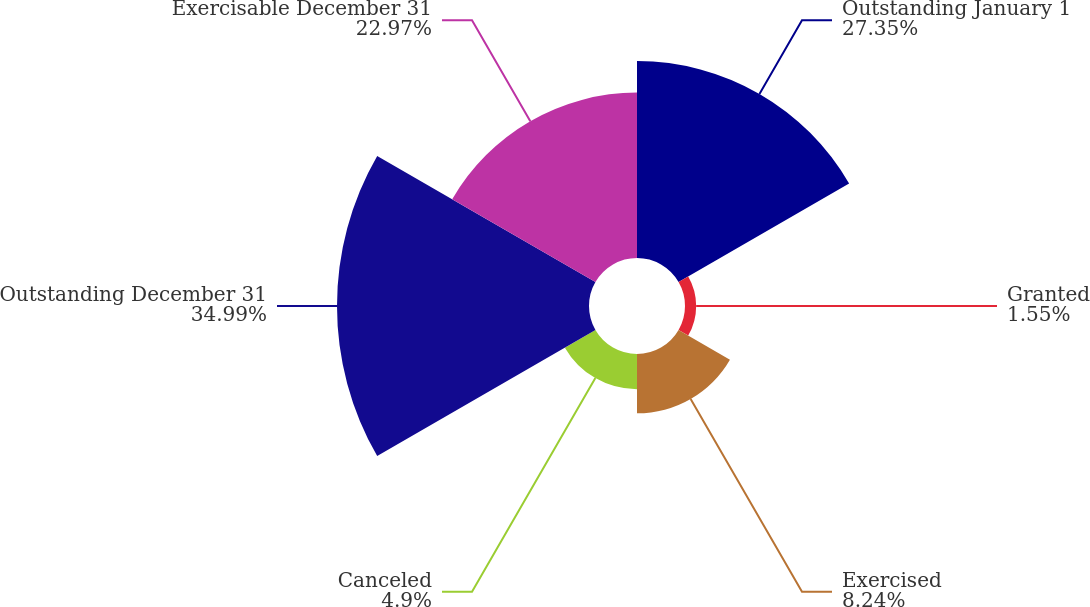<chart> <loc_0><loc_0><loc_500><loc_500><pie_chart><fcel>Outstanding January 1<fcel>Granted<fcel>Exercised<fcel>Canceled<fcel>Outstanding December 31<fcel>Exercisable December 31<nl><fcel>27.35%<fcel>1.55%<fcel>8.24%<fcel>4.9%<fcel>35.0%<fcel>22.97%<nl></chart> 